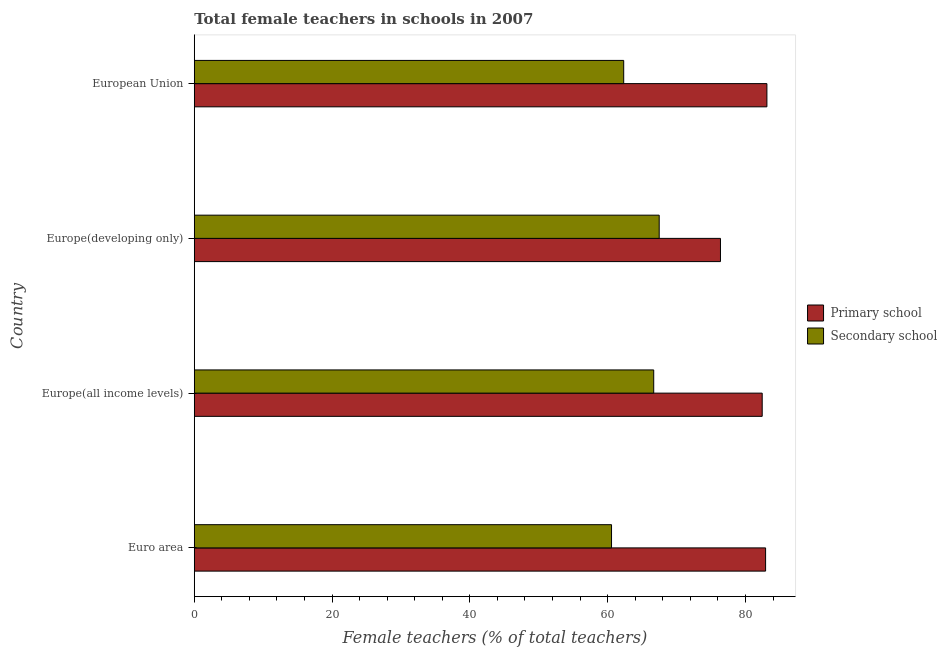Are the number of bars per tick equal to the number of legend labels?
Keep it short and to the point. Yes. How many bars are there on the 3rd tick from the top?
Give a very brief answer. 2. What is the label of the 4th group of bars from the top?
Make the answer very short. Euro area. In how many cases, is the number of bars for a given country not equal to the number of legend labels?
Provide a short and direct response. 0. What is the percentage of female teachers in secondary schools in European Union?
Ensure brevity in your answer.  62.33. Across all countries, what is the maximum percentage of female teachers in secondary schools?
Offer a terse response. 67.48. Across all countries, what is the minimum percentage of female teachers in secondary schools?
Keep it short and to the point. 60.56. In which country was the percentage of female teachers in primary schools maximum?
Your response must be concise. European Union. What is the total percentage of female teachers in primary schools in the graph?
Provide a short and direct response. 324.84. What is the difference between the percentage of female teachers in secondary schools in Europe(all income levels) and that in European Union?
Your answer should be very brief. 4.35. What is the difference between the percentage of female teachers in secondary schools in Europe(all income levels) and the percentage of female teachers in primary schools in Euro area?
Your answer should be very brief. -16.24. What is the average percentage of female teachers in secondary schools per country?
Keep it short and to the point. 64.26. What is the difference between the percentage of female teachers in secondary schools and percentage of female teachers in primary schools in Europe(developing only)?
Offer a very short reply. -8.89. In how many countries, is the percentage of female teachers in primary schools greater than 72 %?
Your response must be concise. 4. What is the ratio of the percentage of female teachers in primary schools in Euro area to that in Europe(developing only)?
Your answer should be very brief. 1.09. Is the percentage of female teachers in secondary schools in Euro area less than that in European Union?
Your answer should be compact. Yes. What is the difference between the highest and the second highest percentage of female teachers in primary schools?
Your response must be concise. 0.19. What is the difference between the highest and the lowest percentage of female teachers in primary schools?
Offer a very short reply. 6.74. In how many countries, is the percentage of female teachers in primary schools greater than the average percentage of female teachers in primary schools taken over all countries?
Offer a very short reply. 3. What does the 2nd bar from the top in European Union represents?
Your answer should be compact. Primary school. What does the 1st bar from the bottom in European Union represents?
Provide a succinct answer. Primary school. How many bars are there?
Offer a very short reply. 8. What is the difference between two consecutive major ticks on the X-axis?
Offer a terse response. 20. Are the values on the major ticks of X-axis written in scientific E-notation?
Your response must be concise. No. How are the legend labels stacked?
Offer a very short reply. Vertical. What is the title of the graph?
Offer a very short reply. Total female teachers in schools in 2007. Does "Commercial service exports" appear as one of the legend labels in the graph?
Your answer should be compact. No. What is the label or title of the X-axis?
Offer a terse response. Female teachers (% of total teachers). What is the label or title of the Y-axis?
Your answer should be compact. Country. What is the Female teachers (% of total teachers) in Primary school in Euro area?
Offer a terse response. 82.92. What is the Female teachers (% of total teachers) in Secondary school in Euro area?
Provide a succinct answer. 60.56. What is the Female teachers (% of total teachers) of Primary school in Europe(all income levels)?
Give a very brief answer. 82.43. What is the Female teachers (% of total teachers) of Secondary school in Europe(all income levels)?
Offer a very short reply. 66.68. What is the Female teachers (% of total teachers) in Primary school in Europe(developing only)?
Your answer should be compact. 76.37. What is the Female teachers (% of total teachers) in Secondary school in Europe(developing only)?
Provide a short and direct response. 67.48. What is the Female teachers (% of total teachers) in Primary school in European Union?
Offer a very short reply. 83.11. What is the Female teachers (% of total teachers) of Secondary school in European Union?
Your response must be concise. 62.33. Across all countries, what is the maximum Female teachers (% of total teachers) in Primary school?
Provide a short and direct response. 83.11. Across all countries, what is the maximum Female teachers (% of total teachers) of Secondary school?
Make the answer very short. 67.48. Across all countries, what is the minimum Female teachers (% of total teachers) in Primary school?
Give a very brief answer. 76.37. Across all countries, what is the minimum Female teachers (% of total teachers) in Secondary school?
Your response must be concise. 60.56. What is the total Female teachers (% of total teachers) of Primary school in the graph?
Give a very brief answer. 324.84. What is the total Female teachers (% of total teachers) in Secondary school in the graph?
Provide a short and direct response. 257.06. What is the difference between the Female teachers (% of total teachers) in Primary school in Euro area and that in Europe(all income levels)?
Make the answer very short. 0.49. What is the difference between the Female teachers (% of total teachers) in Secondary school in Euro area and that in Europe(all income levels)?
Keep it short and to the point. -6.12. What is the difference between the Female teachers (% of total teachers) in Primary school in Euro area and that in Europe(developing only)?
Ensure brevity in your answer.  6.55. What is the difference between the Female teachers (% of total teachers) of Secondary school in Euro area and that in Europe(developing only)?
Ensure brevity in your answer.  -6.92. What is the difference between the Female teachers (% of total teachers) of Primary school in Euro area and that in European Union?
Give a very brief answer. -0.19. What is the difference between the Female teachers (% of total teachers) in Secondary school in Euro area and that in European Union?
Your response must be concise. -1.77. What is the difference between the Female teachers (% of total teachers) of Primary school in Europe(all income levels) and that in Europe(developing only)?
Make the answer very short. 6.06. What is the difference between the Female teachers (% of total teachers) in Secondary school in Europe(all income levels) and that in Europe(developing only)?
Give a very brief answer. -0.8. What is the difference between the Female teachers (% of total teachers) in Primary school in Europe(all income levels) and that in European Union?
Give a very brief answer. -0.68. What is the difference between the Female teachers (% of total teachers) in Secondary school in Europe(all income levels) and that in European Union?
Provide a short and direct response. 4.35. What is the difference between the Female teachers (% of total teachers) in Primary school in Europe(developing only) and that in European Union?
Your answer should be very brief. -6.74. What is the difference between the Female teachers (% of total teachers) in Secondary school in Europe(developing only) and that in European Union?
Keep it short and to the point. 5.15. What is the difference between the Female teachers (% of total teachers) in Primary school in Euro area and the Female teachers (% of total teachers) in Secondary school in Europe(all income levels)?
Offer a very short reply. 16.24. What is the difference between the Female teachers (% of total teachers) in Primary school in Euro area and the Female teachers (% of total teachers) in Secondary school in Europe(developing only)?
Provide a succinct answer. 15.44. What is the difference between the Female teachers (% of total teachers) of Primary school in Euro area and the Female teachers (% of total teachers) of Secondary school in European Union?
Your response must be concise. 20.59. What is the difference between the Female teachers (% of total teachers) in Primary school in Europe(all income levels) and the Female teachers (% of total teachers) in Secondary school in Europe(developing only)?
Ensure brevity in your answer.  14.95. What is the difference between the Female teachers (% of total teachers) in Primary school in Europe(all income levels) and the Female teachers (% of total teachers) in Secondary school in European Union?
Provide a succinct answer. 20.1. What is the difference between the Female teachers (% of total teachers) of Primary school in Europe(developing only) and the Female teachers (% of total teachers) of Secondary school in European Union?
Give a very brief answer. 14.04. What is the average Female teachers (% of total teachers) in Primary school per country?
Offer a terse response. 81.21. What is the average Female teachers (% of total teachers) of Secondary school per country?
Ensure brevity in your answer.  64.26. What is the difference between the Female teachers (% of total teachers) of Primary school and Female teachers (% of total teachers) of Secondary school in Euro area?
Make the answer very short. 22.36. What is the difference between the Female teachers (% of total teachers) of Primary school and Female teachers (% of total teachers) of Secondary school in Europe(all income levels)?
Provide a succinct answer. 15.75. What is the difference between the Female teachers (% of total teachers) in Primary school and Female teachers (% of total teachers) in Secondary school in Europe(developing only)?
Ensure brevity in your answer.  8.89. What is the difference between the Female teachers (% of total teachers) in Primary school and Female teachers (% of total teachers) in Secondary school in European Union?
Your answer should be very brief. 20.78. What is the ratio of the Female teachers (% of total teachers) in Primary school in Euro area to that in Europe(all income levels)?
Offer a very short reply. 1.01. What is the ratio of the Female teachers (% of total teachers) in Secondary school in Euro area to that in Europe(all income levels)?
Your answer should be very brief. 0.91. What is the ratio of the Female teachers (% of total teachers) of Primary school in Euro area to that in Europe(developing only)?
Keep it short and to the point. 1.09. What is the ratio of the Female teachers (% of total teachers) of Secondary school in Euro area to that in Europe(developing only)?
Offer a terse response. 0.9. What is the ratio of the Female teachers (% of total teachers) of Secondary school in Euro area to that in European Union?
Keep it short and to the point. 0.97. What is the ratio of the Female teachers (% of total teachers) in Primary school in Europe(all income levels) to that in Europe(developing only)?
Keep it short and to the point. 1.08. What is the ratio of the Female teachers (% of total teachers) in Secondary school in Europe(all income levels) to that in Europe(developing only)?
Ensure brevity in your answer.  0.99. What is the ratio of the Female teachers (% of total teachers) in Secondary school in Europe(all income levels) to that in European Union?
Offer a terse response. 1.07. What is the ratio of the Female teachers (% of total teachers) of Primary school in Europe(developing only) to that in European Union?
Make the answer very short. 0.92. What is the ratio of the Female teachers (% of total teachers) of Secondary school in Europe(developing only) to that in European Union?
Your answer should be very brief. 1.08. What is the difference between the highest and the second highest Female teachers (% of total teachers) in Primary school?
Provide a short and direct response. 0.19. What is the difference between the highest and the second highest Female teachers (% of total teachers) of Secondary school?
Provide a short and direct response. 0.8. What is the difference between the highest and the lowest Female teachers (% of total teachers) of Primary school?
Offer a very short reply. 6.74. What is the difference between the highest and the lowest Female teachers (% of total teachers) in Secondary school?
Give a very brief answer. 6.92. 